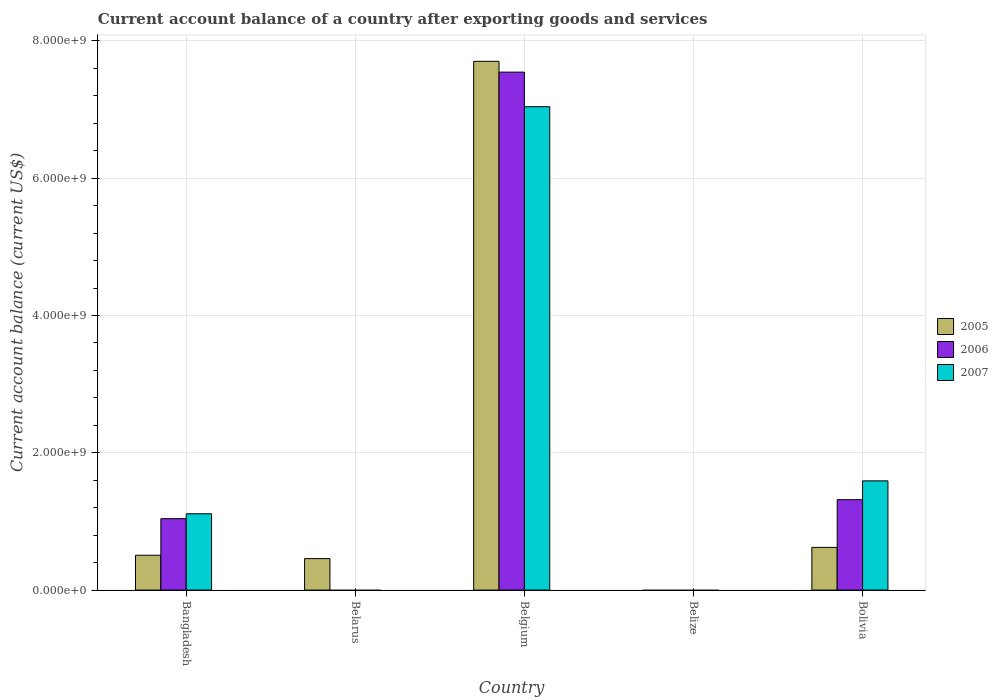How many different coloured bars are there?
Your response must be concise. 3. How many bars are there on the 4th tick from the right?
Provide a succinct answer. 1. What is the label of the 1st group of bars from the left?
Offer a very short reply. Bangladesh. What is the account balance in 2007 in Bolivia?
Make the answer very short. 1.59e+09. Across all countries, what is the maximum account balance in 2007?
Offer a terse response. 7.04e+09. In which country was the account balance in 2006 maximum?
Provide a succinct answer. Belgium. What is the total account balance in 2006 in the graph?
Give a very brief answer. 9.90e+09. What is the difference between the account balance in 2005 in Belarus and that in Bolivia?
Ensure brevity in your answer.  -1.64e+08. What is the difference between the account balance in 2005 in Bolivia and the account balance in 2006 in Bangladesh?
Offer a terse response. -4.18e+08. What is the average account balance in 2007 per country?
Your response must be concise. 1.95e+09. What is the difference between the account balance of/in 2007 and account balance of/in 2006 in Bangladesh?
Your answer should be very brief. 7.13e+07. What is the ratio of the account balance in 2005 in Bangladesh to that in Belgium?
Make the answer very short. 0.07. Is the account balance in 2005 in Bangladesh less than that in Bolivia?
Make the answer very short. Yes. Is the difference between the account balance in 2007 in Bangladesh and Belgium greater than the difference between the account balance in 2006 in Bangladesh and Belgium?
Provide a short and direct response. Yes. What is the difference between the highest and the second highest account balance in 2007?
Offer a very short reply. -5.45e+09. What is the difference between the highest and the lowest account balance in 2006?
Your answer should be compact. 7.55e+09. In how many countries, is the account balance in 2005 greater than the average account balance in 2005 taken over all countries?
Provide a succinct answer. 1. Is the sum of the account balance in 2005 in Bangladesh and Belgium greater than the maximum account balance in 2007 across all countries?
Offer a terse response. Yes. Is it the case that in every country, the sum of the account balance in 2006 and account balance in 2005 is greater than the account balance in 2007?
Ensure brevity in your answer.  No. Are all the bars in the graph horizontal?
Your answer should be compact. No. How many countries are there in the graph?
Your answer should be compact. 5. Does the graph contain any zero values?
Provide a short and direct response. Yes. Does the graph contain grids?
Offer a very short reply. Yes. How many legend labels are there?
Offer a terse response. 3. How are the legend labels stacked?
Offer a terse response. Vertical. What is the title of the graph?
Ensure brevity in your answer.  Current account balance of a country after exporting goods and services. What is the label or title of the Y-axis?
Ensure brevity in your answer.  Current account balance (current US$). What is the Current account balance (current US$) in 2005 in Bangladesh?
Offer a terse response. 5.08e+08. What is the Current account balance (current US$) of 2006 in Bangladesh?
Make the answer very short. 1.04e+09. What is the Current account balance (current US$) of 2007 in Bangladesh?
Provide a short and direct response. 1.11e+09. What is the Current account balance (current US$) of 2005 in Belarus?
Ensure brevity in your answer.  4.59e+08. What is the Current account balance (current US$) in 2005 in Belgium?
Provide a short and direct response. 7.70e+09. What is the Current account balance (current US$) of 2006 in Belgium?
Ensure brevity in your answer.  7.55e+09. What is the Current account balance (current US$) of 2007 in Belgium?
Your answer should be very brief. 7.04e+09. What is the Current account balance (current US$) in 2006 in Belize?
Make the answer very short. 0. What is the Current account balance (current US$) of 2005 in Bolivia?
Offer a very short reply. 6.22e+08. What is the Current account balance (current US$) of 2006 in Bolivia?
Keep it short and to the point. 1.32e+09. What is the Current account balance (current US$) in 2007 in Bolivia?
Provide a succinct answer. 1.59e+09. Across all countries, what is the maximum Current account balance (current US$) in 2005?
Give a very brief answer. 7.70e+09. Across all countries, what is the maximum Current account balance (current US$) of 2006?
Provide a succinct answer. 7.55e+09. Across all countries, what is the maximum Current account balance (current US$) of 2007?
Provide a short and direct response. 7.04e+09. Across all countries, what is the minimum Current account balance (current US$) in 2006?
Offer a terse response. 0. What is the total Current account balance (current US$) of 2005 in the graph?
Your answer should be compact. 9.29e+09. What is the total Current account balance (current US$) in 2006 in the graph?
Ensure brevity in your answer.  9.90e+09. What is the total Current account balance (current US$) of 2007 in the graph?
Provide a short and direct response. 9.74e+09. What is the difference between the Current account balance (current US$) in 2005 in Bangladesh and that in Belarus?
Your answer should be very brief. 4.91e+07. What is the difference between the Current account balance (current US$) in 2005 in Bangladesh and that in Belgium?
Your answer should be very brief. -7.19e+09. What is the difference between the Current account balance (current US$) of 2006 in Bangladesh and that in Belgium?
Provide a succinct answer. -6.50e+09. What is the difference between the Current account balance (current US$) of 2007 in Bangladesh and that in Belgium?
Keep it short and to the point. -5.93e+09. What is the difference between the Current account balance (current US$) in 2005 in Bangladesh and that in Bolivia?
Provide a short and direct response. -1.15e+08. What is the difference between the Current account balance (current US$) in 2006 in Bangladesh and that in Bolivia?
Keep it short and to the point. -2.77e+08. What is the difference between the Current account balance (current US$) of 2007 in Bangladesh and that in Bolivia?
Your answer should be compact. -4.79e+08. What is the difference between the Current account balance (current US$) of 2005 in Belarus and that in Belgium?
Ensure brevity in your answer.  -7.24e+09. What is the difference between the Current account balance (current US$) in 2005 in Belarus and that in Bolivia?
Offer a terse response. -1.64e+08. What is the difference between the Current account balance (current US$) of 2005 in Belgium and that in Bolivia?
Ensure brevity in your answer.  7.08e+09. What is the difference between the Current account balance (current US$) in 2006 in Belgium and that in Bolivia?
Your answer should be compact. 6.23e+09. What is the difference between the Current account balance (current US$) of 2007 in Belgium and that in Bolivia?
Make the answer very short. 5.45e+09. What is the difference between the Current account balance (current US$) in 2005 in Bangladesh and the Current account balance (current US$) in 2006 in Belgium?
Provide a succinct answer. -7.04e+09. What is the difference between the Current account balance (current US$) in 2005 in Bangladesh and the Current account balance (current US$) in 2007 in Belgium?
Your answer should be very brief. -6.53e+09. What is the difference between the Current account balance (current US$) in 2006 in Bangladesh and the Current account balance (current US$) in 2007 in Belgium?
Give a very brief answer. -6.00e+09. What is the difference between the Current account balance (current US$) in 2005 in Bangladesh and the Current account balance (current US$) in 2006 in Bolivia?
Your answer should be very brief. -8.10e+08. What is the difference between the Current account balance (current US$) of 2005 in Bangladesh and the Current account balance (current US$) of 2007 in Bolivia?
Offer a very short reply. -1.08e+09. What is the difference between the Current account balance (current US$) in 2006 in Bangladesh and the Current account balance (current US$) in 2007 in Bolivia?
Give a very brief answer. -5.51e+08. What is the difference between the Current account balance (current US$) of 2005 in Belarus and the Current account balance (current US$) of 2006 in Belgium?
Provide a short and direct response. -7.09e+09. What is the difference between the Current account balance (current US$) of 2005 in Belarus and the Current account balance (current US$) of 2007 in Belgium?
Keep it short and to the point. -6.58e+09. What is the difference between the Current account balance (current US$) in 2005 in Belarus and the Current account balance (current US$) in 2006 in Bolivia?
Give a very brief answer. -8.59e+08. What is the difference between the Current account balance (current US$) in 2005 in Belarus and the Current account balance (current US$) in 2007 in Bolivia?
Ensure brevity in your answer.  -1.13e+09. What is the difference between the Current account balance (current US$) in 2005 in Belgium and the Current account balance (current US$) in 2006 in Bolivia?
Offer a very short reply. 6.39e+09. What is the difference between the Current account balance (current US$) in 2005 in Belgium and the Current account balance (current US$) in 2007 in Bolivia?
Provide a succinct answer. 6.11e+09. What is the difference between the Current account balance (current US$) in 2006 in Belgium and the Current account balance (current US$) in 2007 in Bolivia?
Your answer should be compact. 5.95e+09. What is the average Current account balance (current US$) of 2005 per country?
Offer a very short reply. 1.86e+09. What is the average Current account balance (current US$) in 2006 per country?
Make the answer very short. 1.98e+09. What is the average Current account balance (current US$) in 2007 per country?
Your response must be concise. 1.95e+09. What is the difference between the Current account balance (current US$) in 2005 and Current account balance (current US$) in 2006 in Bangladesh?
Provide a succinct answer. -5.33e+08. What is the difference between the Current account balance (current US$) of 2005 and Current account balance (current US$) of 2007 in Bangladesh?
Your answer should be compact. -6.04e+08. What is the difference between the Current account balance (current US$) in 2006 and Current account balance (current US$) in 2007 in Bangladesh?
Offer a terse response. -7.13e+07. What is the difference between the Current account balance (current US$) of 2005 and Current account balance (current US$) of 2006 in Belgium?
Ensure brevity in your answer.  1.58e+08. What is the difference between the Current account balance (current US$) in 2005 and Current account balance (current US$) in 2007 in Belgium?
Your answer should be very brief. 6.61e+08. What is the difference between the Current account balance (current US$) of 2006 and Current account balance (current US$) of 2007 in Belgium?
Make the answer very short. 5.04e+08. What is the difference between the Current account balance (current US$) in 2005 and Current account balance (current US$) in 2006 in Bolivia?
Your answer should be compact. -6.95e+08. What is the difference between the Current account balance (current US$) in 2005 and Current account balance (current US$) in 2007 in Bolivia?
Make the answer very short. -9.69e+08. What is the difference between the Current account balance (current US$) in 2006 and Current account balance (current US$) in 2007 in Bolivia?
Keep it short and to the point. -2.74e+08. What is the ratio of the Current account balance (current US$) in 2005 in Bangladesh to that in Belarus?
Give a very brief answer. 1.11. What is the ratio of the Current account balance (current US$) of 2005 in Bangladesh to that in Belgium?
Offer a terse response. 0.07. What is the ratio of the Current account balance (current US$) in 2006 in Bangladesh to that in Belgium?
Offer a very short reply. 0.14. What is the ratio of the Current account balance (current US$) of 2007 in Bangladesh to that in Belgium?
Make the answer very short. 0.16. What is the ratio of the Current account balance (current US$) of 2005 in Bangladesh to that in Bolivia?
Provide a short and direct response. 0.82. What is the ratio of the Current account balance (current US$) in 2006 in Bangladesh to that in Bolivia?
Make the answer very short. 0.79. What is the ratio of the Current account balance (current US$) of 2007 in Bangladesh to that in Bolivia?
Make the answer very short. 0.7. What is the ratio of the Current account balance (current US$) of 2005 in Belarus to that in Belgium?
Provide a short and direct response. 0.06. What is the ratio of the Current account balance (current US$) in 2005 in Belarus to that in Bolivia?
Your response must be concise. 0.74. What is the ratio of the Current account balance (current US$) of 2005 in Belgium to that in Bolivia?
Offer a very short reply. 12.37. What is the ratio of the Current account balance (current US$) of 2006 in Belgium to that in Bolivia?
Your answer should be compact. 5.73. What is the ratio of the Current account balance (current US$) in 2007 in Belgium to that in Bolivia?
Ensure brevity in your answer.  4.42. What is the difference between the highest and the second highest Current account balance (current US$) of 2005?
Keep it short and to the point. 7.08e+09. What is the difference between the highest and the second highest Current account balance (current US$) in 2006?
Your response must be concise. 6.23e+09. What is the difference between the highest and the second highest Current account balance (current US$) of 2007?
Provide a short and direct response. 5.45e+09. What is the difference between the highest and the lowest Current account balance (current US$) in 2005?
Your answer should be compact. 7.70e+09. What is the difference between the highest and the lowest Current account balance (current US$) in 2006?
Offer a terse response. 7.55e+09. What is the difference between the highest and the lowest Current account balance (current US$) of 2007?
Ensure brevity in your answer.  7.04e+09. 